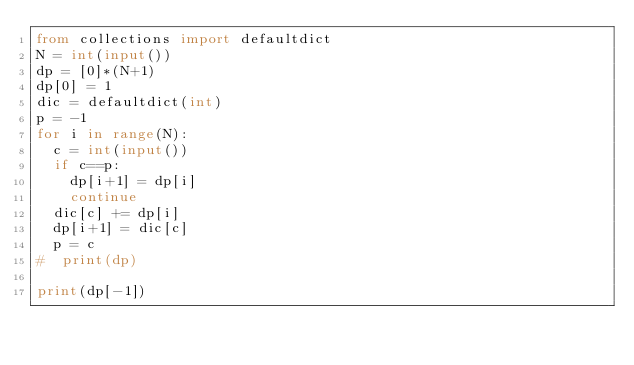<code> <loc_0><loc_0><loc_500><loc_500><_Python_>from collections import defaultdict
N = int(input())
dp = [0]*(N+1)
dp[0] = 1
dic = defaultdict(int)
p = -1
for i in range(N):
  c = int(input())
  if c==p:
    dp[i+1] = dp[i]
    continue
  dic[c] += dp[i]
  dp[i+1] = dic[c]
  p = c
#  print(dp)

print(dp[-1])</code> 